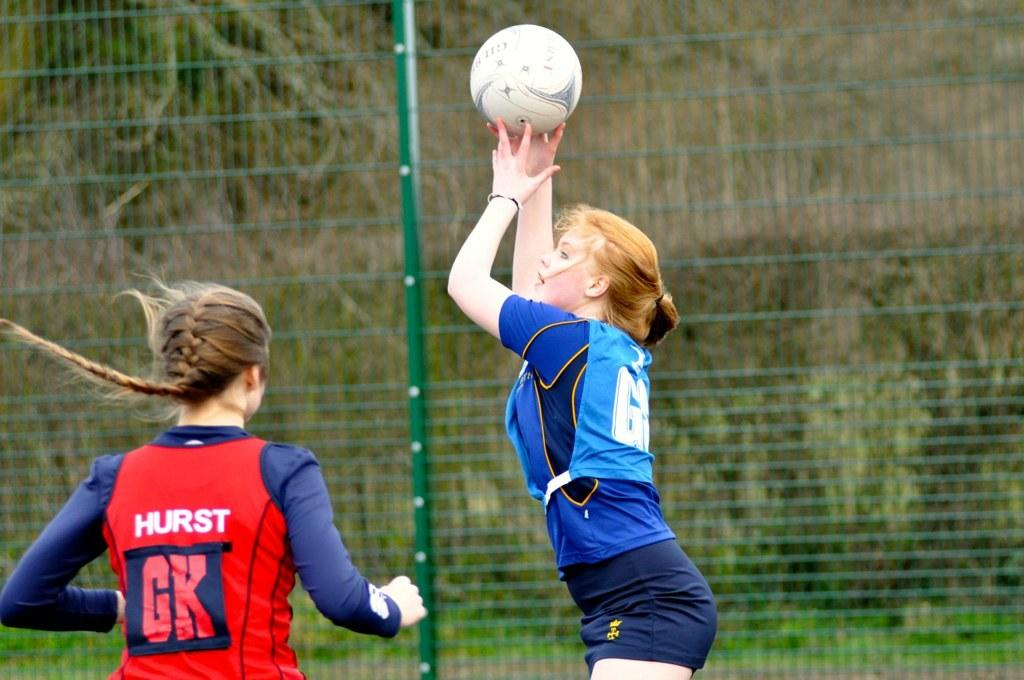How many people are in the image? There are two girls in the image. What are the girls wearing? The girls are wearing jerseys. What is one of the girls holding? One girl is holding a ball. What can be seen in the background of the image? There is a fence in the background of the image. What color is the fence? The fence is green in color. What type of teaching method is being demonstrated by the girls in the image? There is no indication of any teaching method being demonstrated in the image; it simply shows two girls wearing jerseys and one holding a ball. 